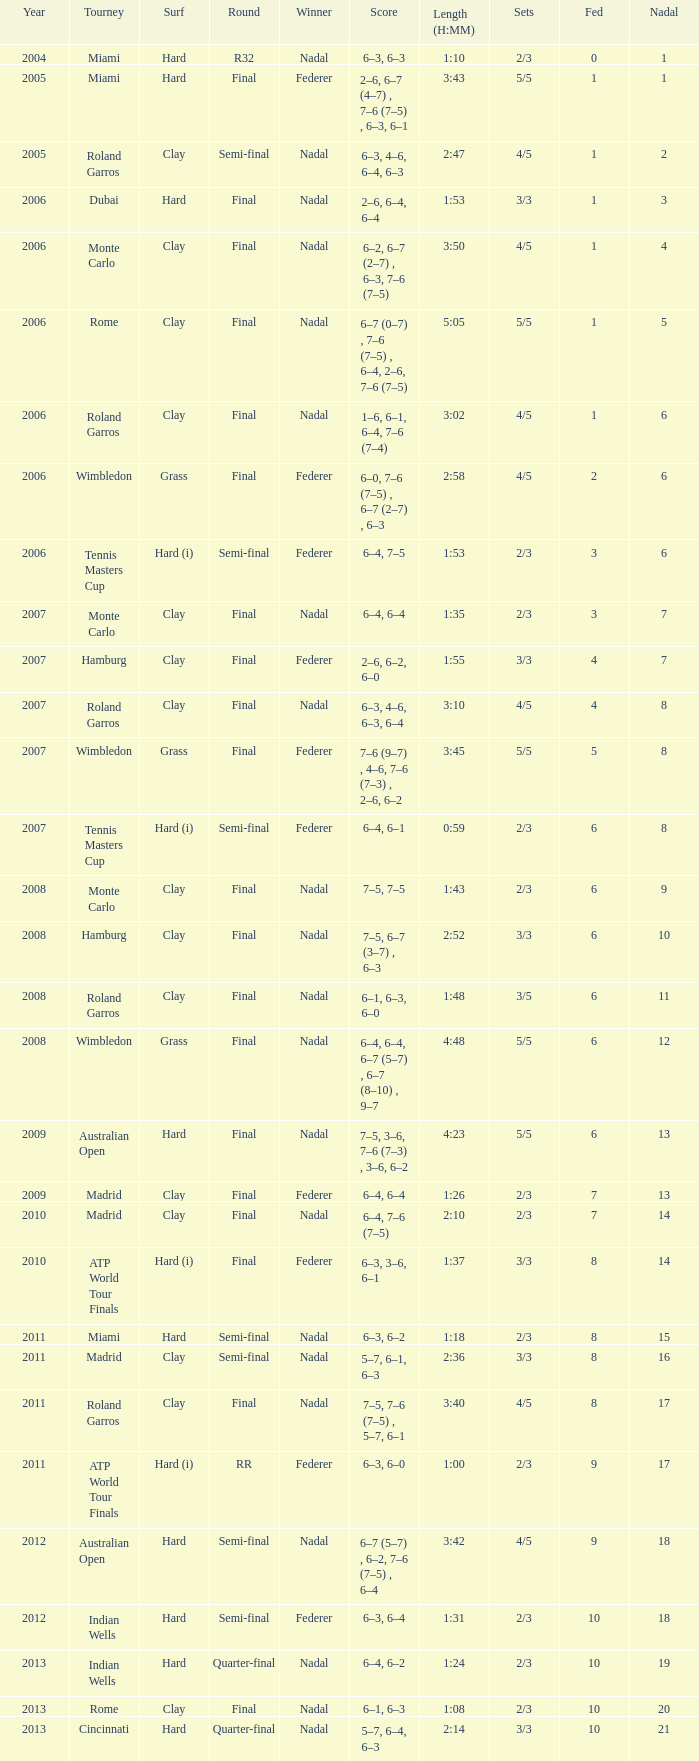What was the nadal in Miami in the final round? 1.0. 